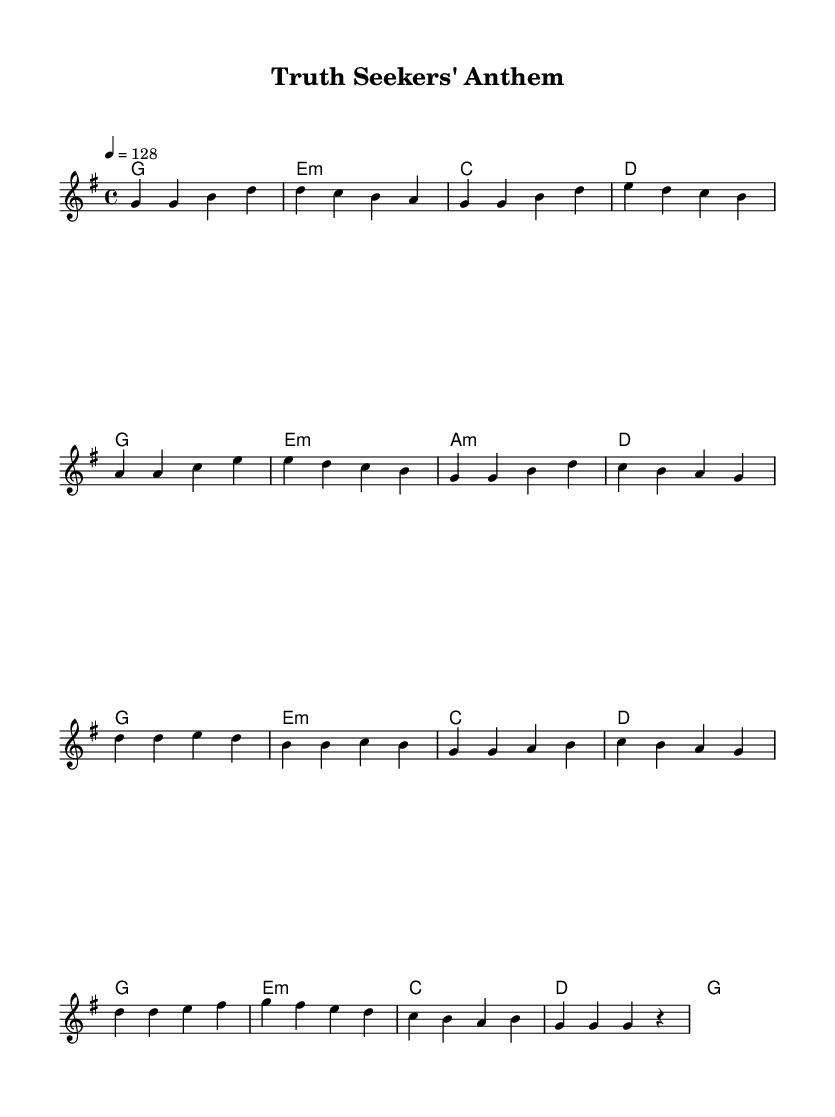What is the key signature of this music? The key signature is G major, which has one sharp (F#). This is indicated at the beginning of the staff where the key signature is placed.
Answer: G major What is the time signature of this music? The time signature is 4/4, which is indicated at the beginning of the score as a common time signature. It means there are four beats in each measure.
Answer: 4/4 What is the tempo marking for this piece? The tempo marking indicates a speed of 128 beats per minute. This is shown in the score with the notation "4 = 128" under the tempo section.
Answer: 128 How many measures are there in the verse? The verse section consists of 8 measures, counted from the beginning of the verse until the end of the chorus transition. Each group of notes separated by vertical lines represents a measure.
Answer: 8 Which chord follows the G major chord in the verse? The G major chord is followed by an E minor chord in the verse. Chords are presented in the chord names section above the melody, marked correspondingly.
Answer: E minor What is the rhythm pattern of the chorus primarily structured around? The chorus primarily uses quarter notes, which are represented by the note heads with stems pointing up or down. The predominance of these note values creates an upbeat feel characteristic of K-Pop.
Answer: Quarter notes What is the main thematic focus of the lyrics implied in this piece? The thematic focus suggests a celebration of investigative journalism, as indicated by the title "Truth Seekers' Anthem." This title conveys a message of seeking the truth, fitting for the context of K-Pop tracks that often convey strong messages.
Answer: Investigative journalism 